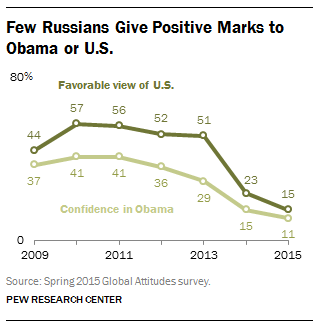Specify some key components in this picture. Of the values displayed in the light green graph, 2 of them are equal. The rightmost value of the dark green graph is 15. 